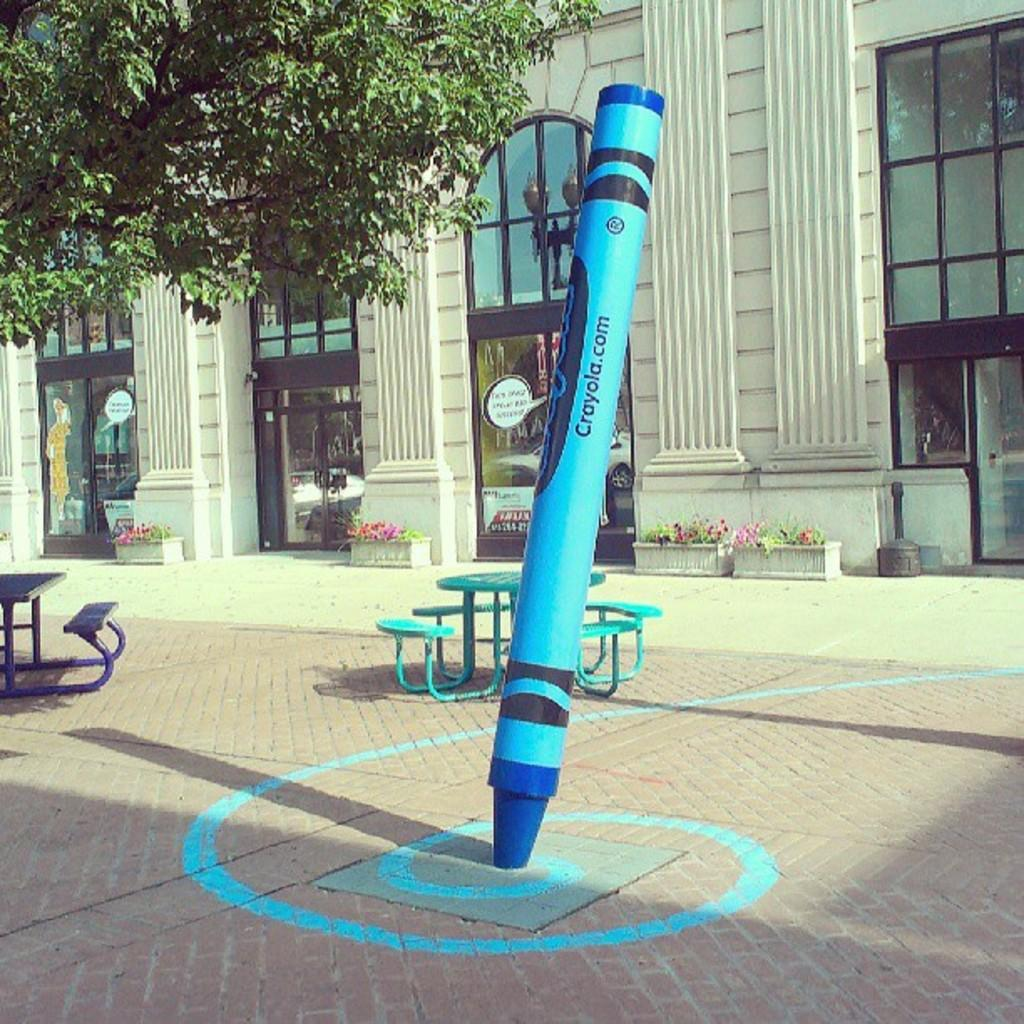What is the main structure in the image? There is a building in the middle of the image. What features can be seen on the building? The building has doors. What type of vegetation is present in the image? There is a tree in the top left corner of the image. What objects are in the middle of the image? There are benches in the middle of the image. What is the tendency of the building to give birth to new structures in the image? The building does not have a tendency to give birth to new structures in the image; it is a single, stationary building. 